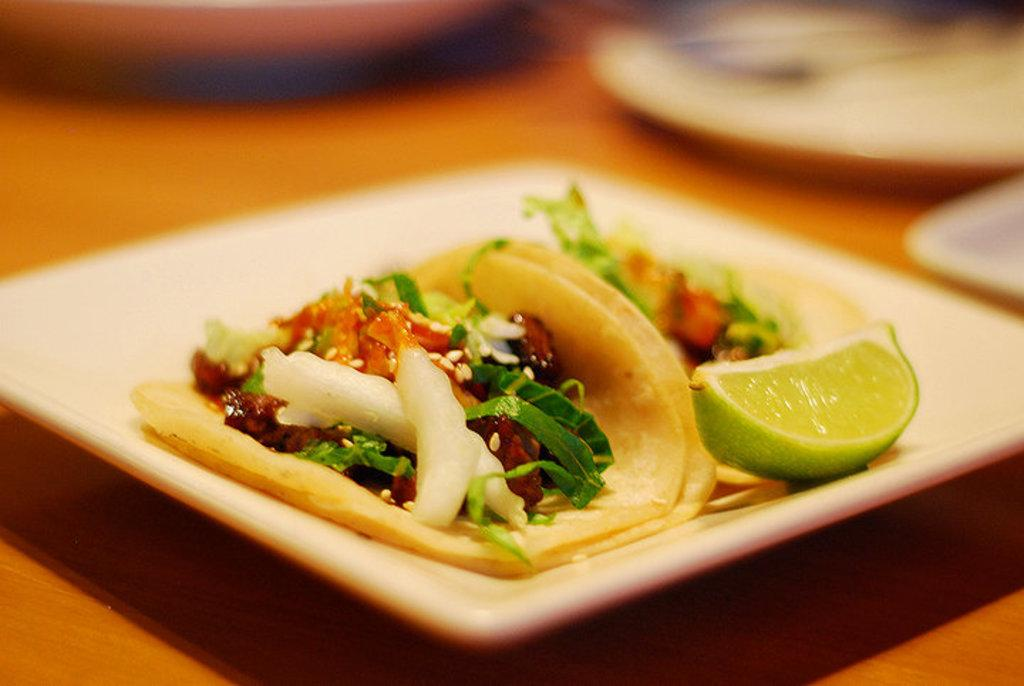What is on the plate that is visible in the image? There is a white plate in the image, and on it, there is lemon. Are there any other food items on the plate besides the lemon? Yes, there are food items on the plate. What type of instrument can be seen being played on the plate in the image? There is no instrument present on the plate in the image; it contains a white plate with lemon and other food items. How many books are visible on the plate in the image? There are no books present on the plate in the image. 